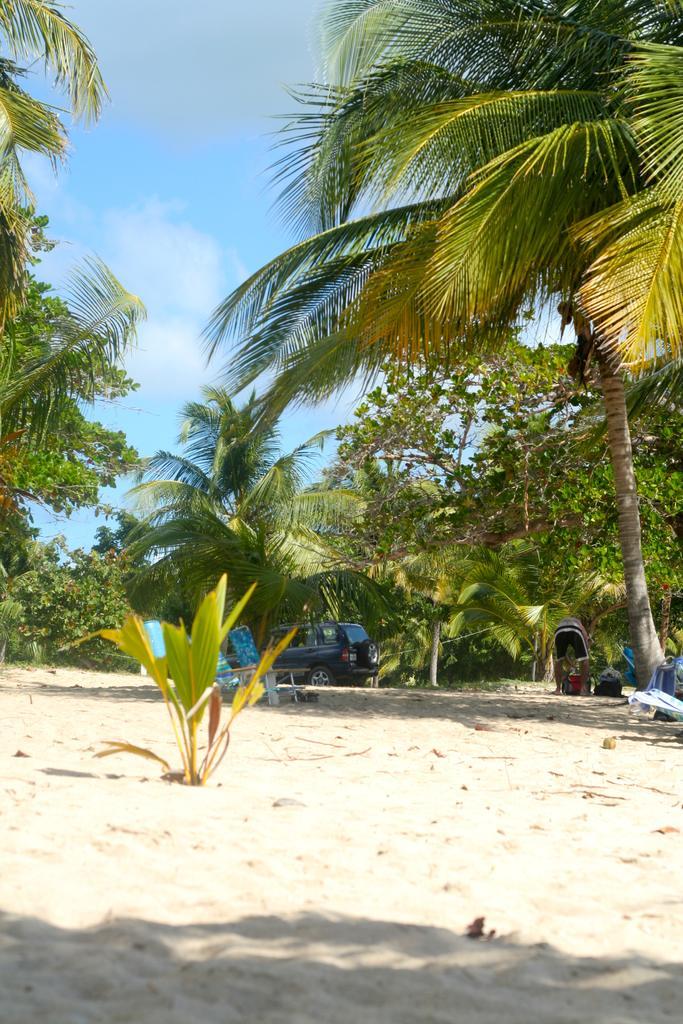How would you summarize this image in a sentence or two? In this picture we can see a vehicle on the land, around we can see some plants and trees. 